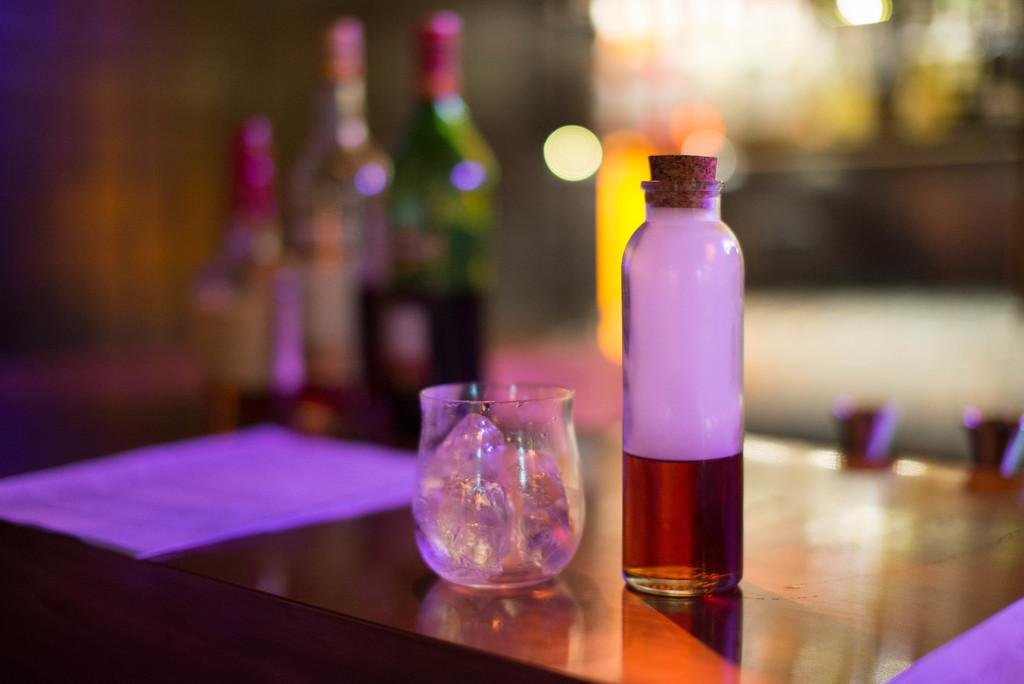What is on the table in the image? There is a bottle with a closed cap and liquid in it, as well as a glass with ice cubes on the table. What is behind the first bottle and glass on the table? There are three wine bottles behind the first bottle and glass. What is behind the wine bottles on the table? There is a bunch of papers behind the wine bottles. What type of dinosaurs can be seen in the image? There are no dinosaurs present in the image. What does the queen do in the image? There is no queen present in the image. 